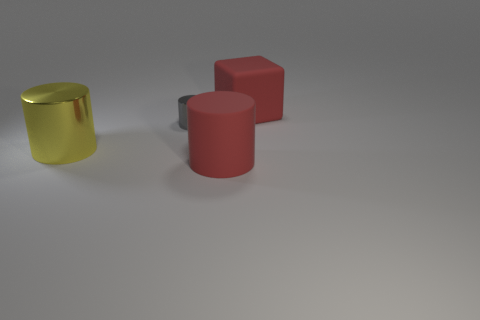Add 1 blue shiny cubes. How many objects exist? 5 Subtract all cylinders. How many objects are left? 1 Add 1 gray metal cylinders. How many gray metal cylinders are left? 2 Add 3 metallic things. How many metallic things exist? 5 Subtract 0 cyan cylinders. How many objects are left? 4 Subtract all big yellow metal objects. Subtract all blue rubber spheres. How many objects are left? 3 